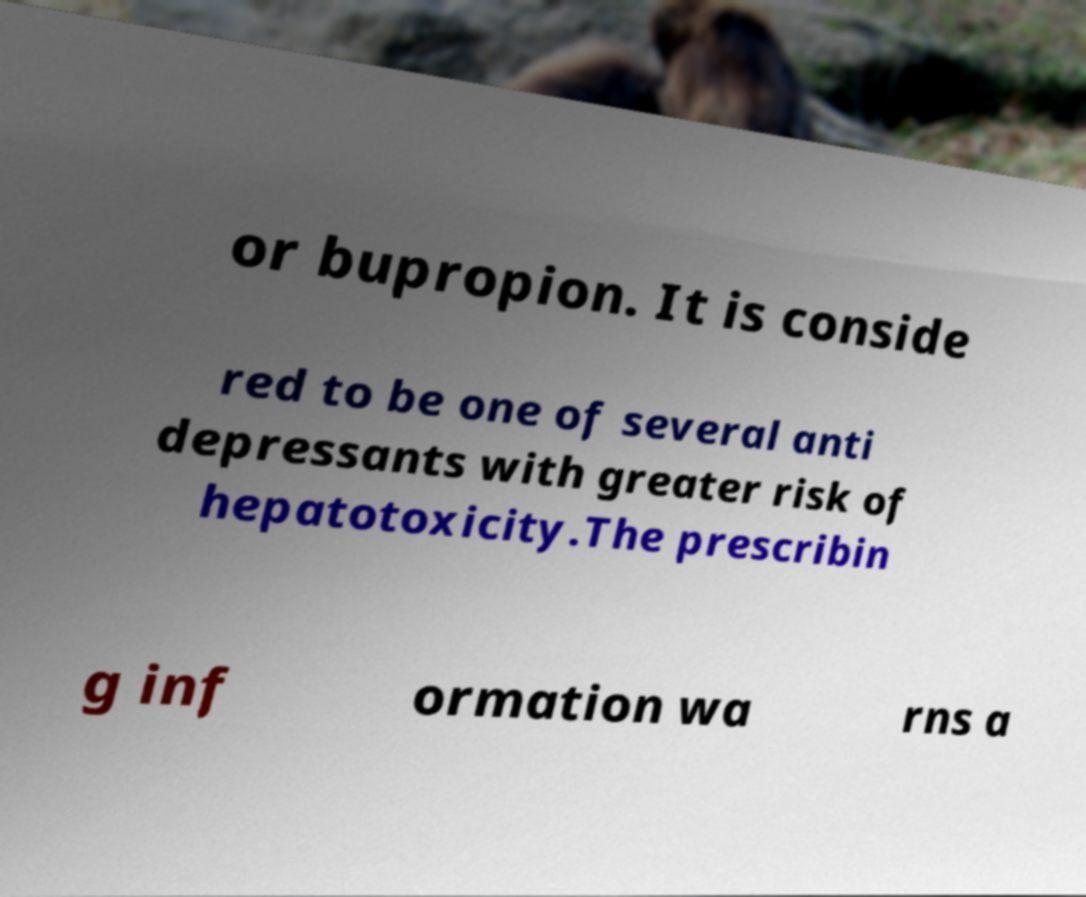There's text embedded in this image that I need extracted. Can you transcribe it verbatim? or bupropion. It is conside red to be one of several anti depressants with greater risk of hepatotoxicity.The prescribin g inf ormation wa rns a 